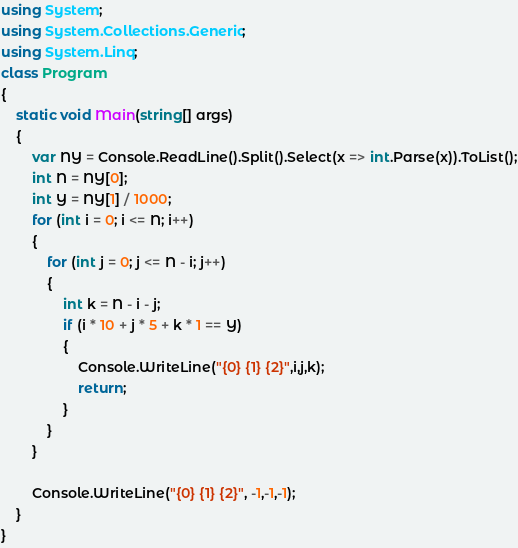<code> <loc_0><loc_0><loc_500><loc_500><_C#_>using System;
using System.Collections.Generic;
using System.Linq;
class Program
{
    static void Main(string[] args)
    {
        var NY = Console.ReadLine().Split().Select(x => int.Parse(x)).ToList();
        int N = NY[0];
        int Y = NY[1] / 1000;
        for (int i = 0; i <= N; i++)
        {
            for (int j = 0; j <= N - i; j++)
            {
                int k = N - i - j;
                if (i * 10 + j * 5 + k * 1 == Y)
                {
                    Console.WriteLine("{0} {1} {2}",i,j,k);
                    return;
                }
            }
        }

        Console.WriteLine("{0} {1} {2}", -1,-1,-1);
    }
}</code> 